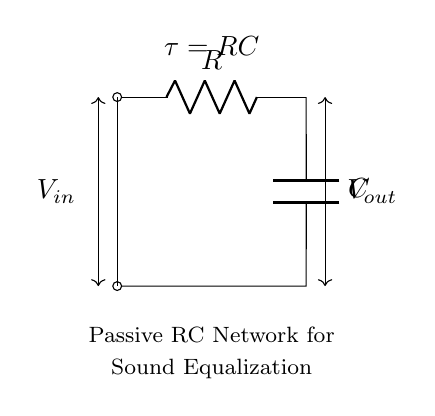What are the two components used in this circuit? The circuit contains a resistor (R) and a capacitor (C), as labeled in the diagram. The labels are clearly indicated in the schematic.
Answer: Resistor and capacitor What is the function of the resistor in this RC network? The resistor limits the current flow into the capacitor, controlling the time constant of the circuit, which affects charging and discharging rates. This is crucial for sound equalization as it influences the frequency response.
Answer: Current limiting What does the symbol V in the circuit stand for? The symbol V represents voltage; specifically, V_in is the input voltage, and V_out is the output voltage from the circuit. The voltage levels indicate the potential differences across the components in the circuit.
Answer: Voltage What is the time constant of this RC circuit? The time constant, denoted as τ, is calculated by the formula τ = R * C, where R is the resistance and C is the capacitance. This constant determines how quickly the circuit responds to changes in voltage.
Answer: R times C How does the capacitor affect the output voltage? The capacitor stores electrical energy and impacts the output voltage by integrating (or averaging) the input voltage over time. This modulation results in a smoother sound output, which is essential for equalization.
Answer: Smoothing sound What type of network is represented in this circuit? The circuit is a passive RC network as it contains passive components only (resistor and capacitor) without any active components like transistors or operational amplifiers. Passive networks are used for filtering signals.
Answer: Passive RC network What role does the output voltage play in sound equalization? The output voltage represents the modified sound signal after processing through the RC network. It is essential for equalization as it determines the tonal quality and balance of different frequency components in sound.
Answer: Modified sound signal 